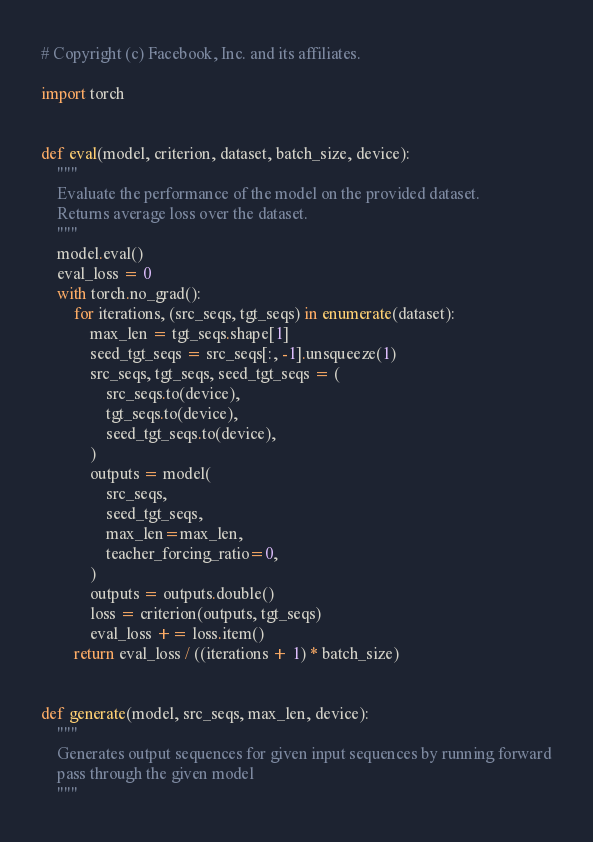<code> <loc_0><loc_0><loc_500><loc_500><_Python_># Copyright (c) Facebook, Inc. and its affiliates.

import torch


def eval(model, criterion, dataset, batch_size, device):
    """
    Evaluate the performance of the model on the provided dataset.
    Returns average loss over the dataset.
    """
    model.eval()
    eval_loss = 0
    with torch.no_grad():
        for iterations, (src_seqs, tgt_seqs) in enumerate(dataset):
            max_len = tgt_seqs.shape[1]
            seed_tgt_seqs = src_seqs[:, -1].unsqueeze(1)
            src_seqs, tgt_seqs, seed_tgt_seqs = (
                src_seqs.to(device),
                tgt_seqs.to(device),
                seed_tgt_seqs.to(device),
            )
            outputs = model(
                src_seqs,
                seed_tgt_seqs,
                max_len=max_len,
                teacher_forcing_ratio=0,
            )
            outputs = outputs.double()
            loss = criterion(outputs, tgt_seqs)
            eval_loss += loss.item()
        return eval_loss / ((iterations + 1) * batch_size)


def generate(model, src_seqs, max_len, device):
    """
    Generates output sequences for given input sequences by running forward
    pass through the given model
    """</code> 